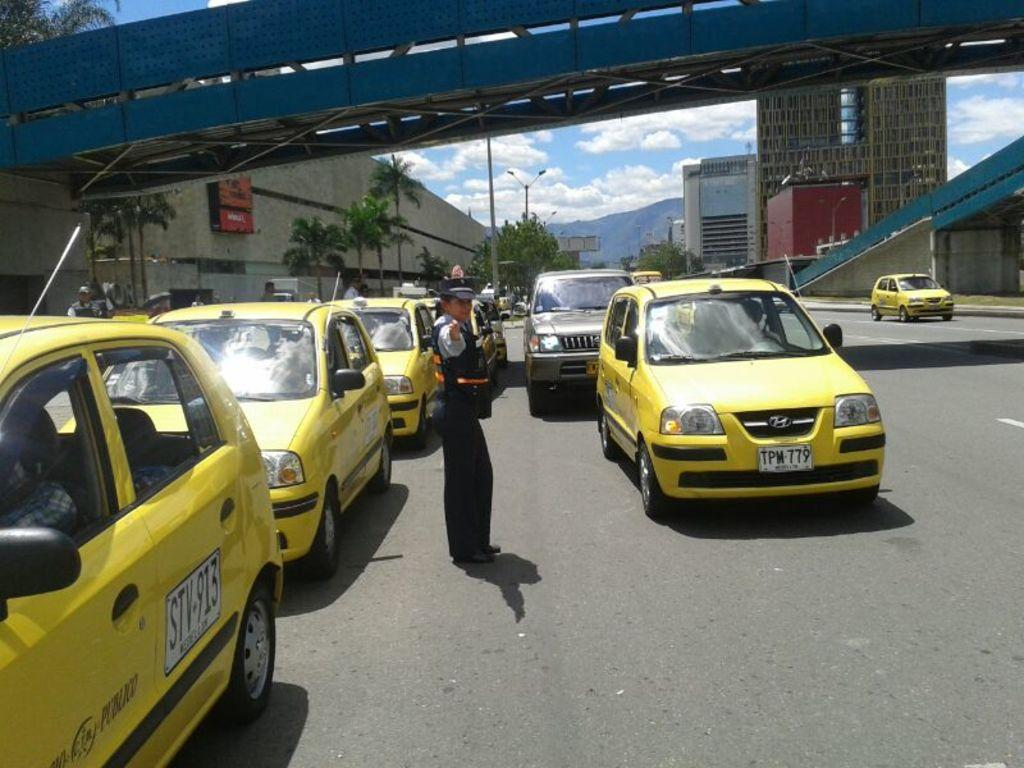<image>
Present a compact description of the photo's key features. A cop directing traffic near a cab with an STV sticker on the side door. 